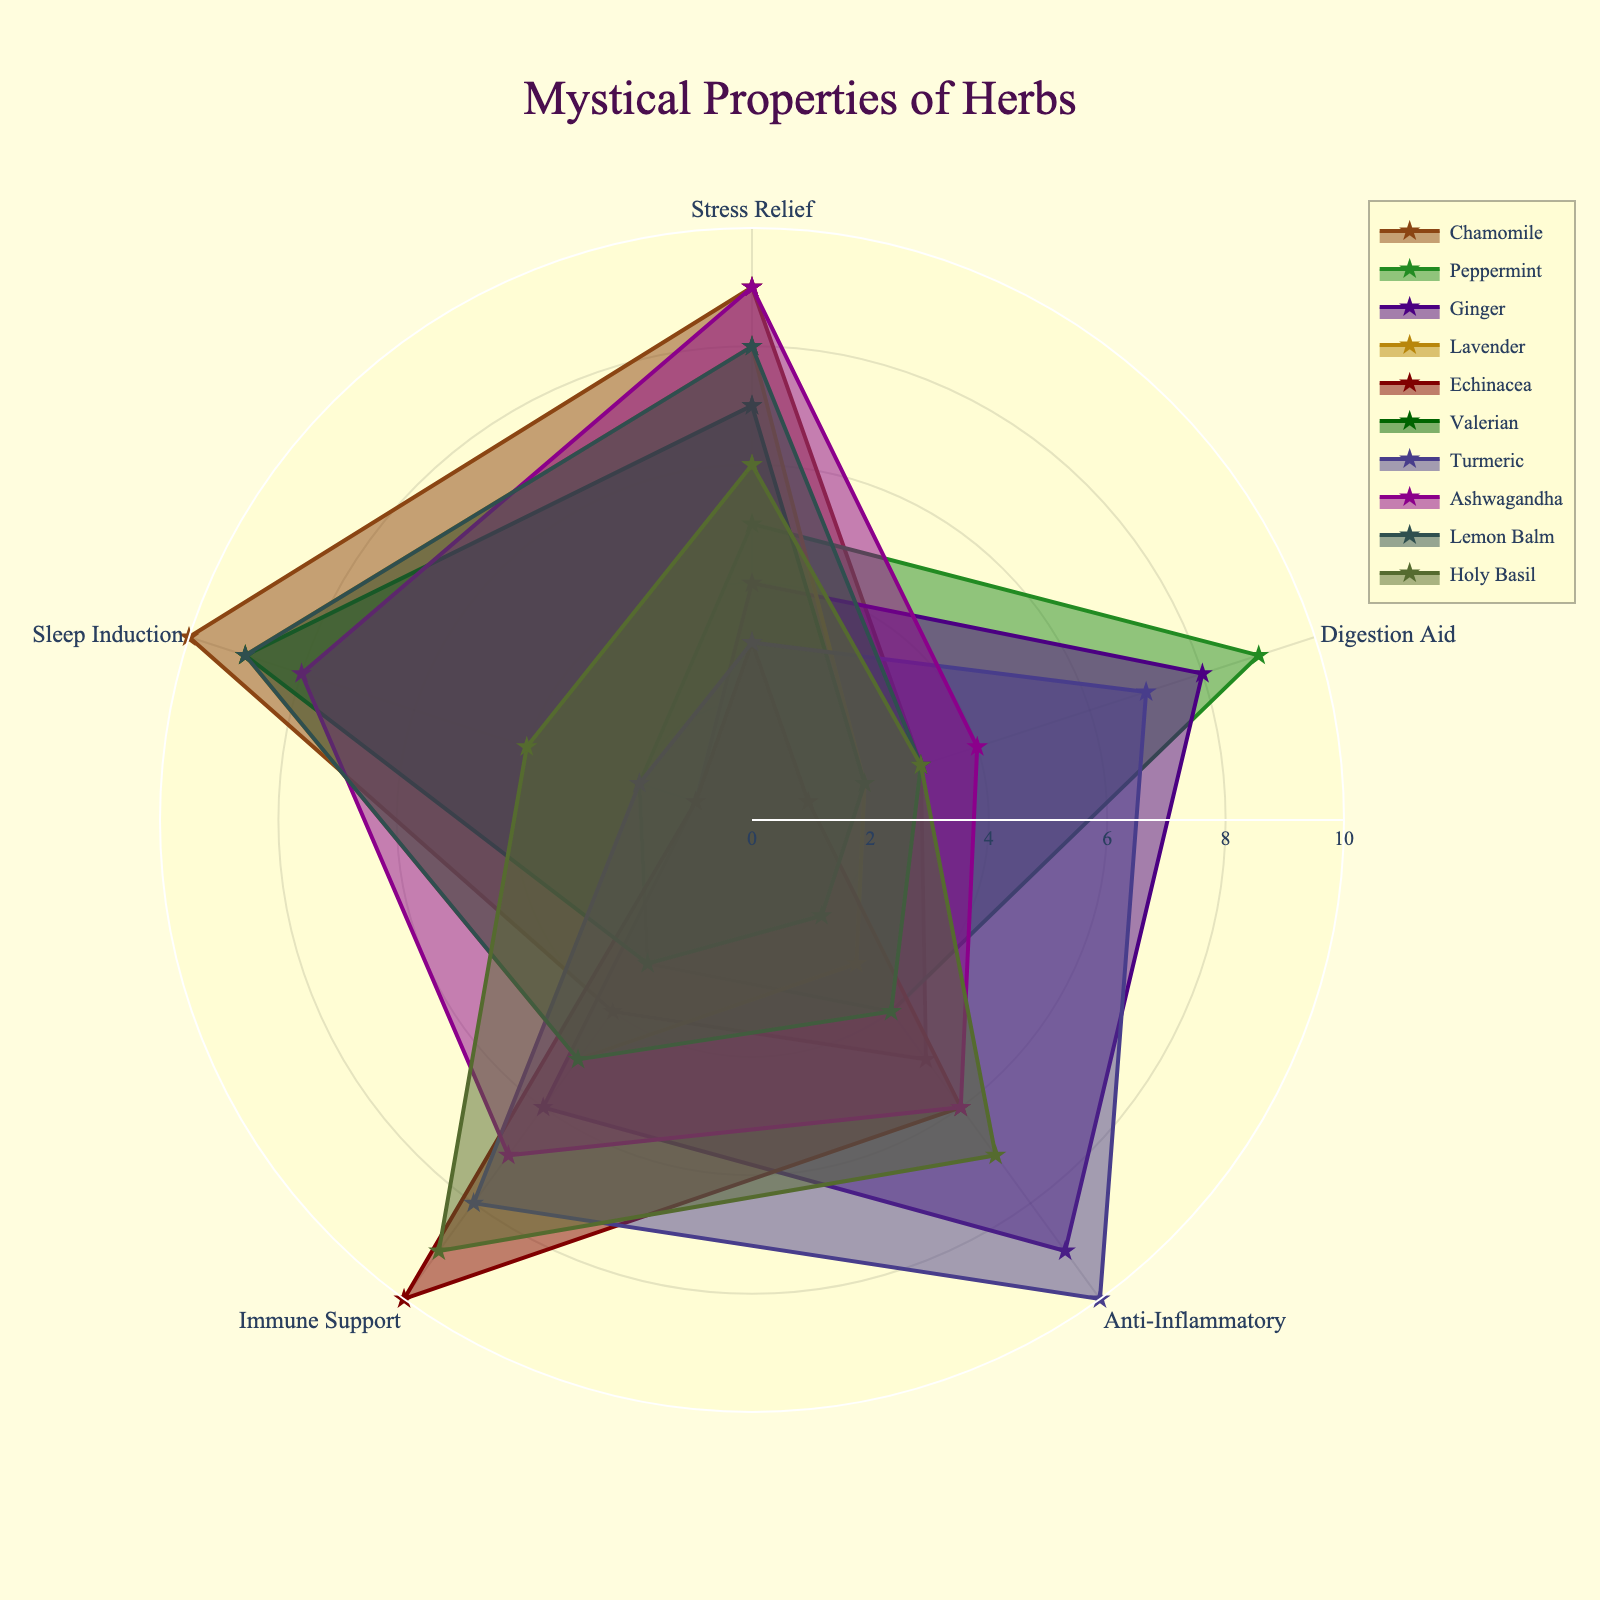what is the title of the radar chart? The title of the radar chart is located at the top center of the plot, and it summarizes the main subject of the figure. By looking at the figure, you can find it underlined as "Mystical Properties of Herbs".
Answer: Mystical Properties of Herbs what is the highest score achieved by Chamomile for any of the health benefits? To determine the highest score for Chamomile, locate the Chamomile plot in the radar chart. Observe the scores for each health benefit (Stress Relief, Digestion Aid, Anti-Inflammatory, Immune Support, and Sleep Induction) and choose the highest value. Chamomile has a Sleep Induction score of 10.
Answer: 10 which herb has the highest score for Immune Support? To find this, refer to the axis representing Immune Support in the radar chart. Trace the plot lines for each herb to see which one extends the furthest along this axis. Echinacea shows the highest score for Immune Support.
Answer: Echinacea what is the sum of the Stress Relief scores for Chamomile and Lavender? Locate Chamomile and Lavender in the radar chart. Identify their Stress Relief scores: Chamomile has 9 and Lavender has 8. Adding these together gives a sum of 9 + 8.
Answer: 17 which herb has equally high scores (9) for both Stress Relief and Sleep Induction? Scan the radar chart to find the herb with equal scores of 9 for both Stress Relief and Sleep Induction. Ashwagandha matches this profile.
Answer: Ashwagandha compare the Sleep Induction scores of Valerian and Lemon Balm. Which has a higher score? Locate Valerian and Lemon Balm in the radar chart and compare their Sleep Induction scores. Valerian has a Sleep Induction score of 9, while Lemon Balm also has a score of 9. They are equal in this aspect.
Answer: Equal which herbs score exactly 7 for Anti-Inflammatory properties? Look at the Anti-Inflammatory axis and find the herbs whose plots intersect at the 7 mark. Holy Basil and Ashwagandha both have scores of 7 for Anti-Inflammatory properties.
Answer: Holy Basil, Ashwagandha how many herbs have a score of 10 in any of the health benefits categories? By reviewing each health benefits category in the radar chart, count the herbs scoring a perfect 10 at least once. Chamomile, Turmeric, and Echinacea each have at least one score of 10.
Answer: 3 which herb shows the least effectiveness for Digestion Aid? Identify the herb with the lowest score for Digestion Aid in the radar chart. Echinacea scores a 1, representing the lowest value.
Answer: Echinacea 